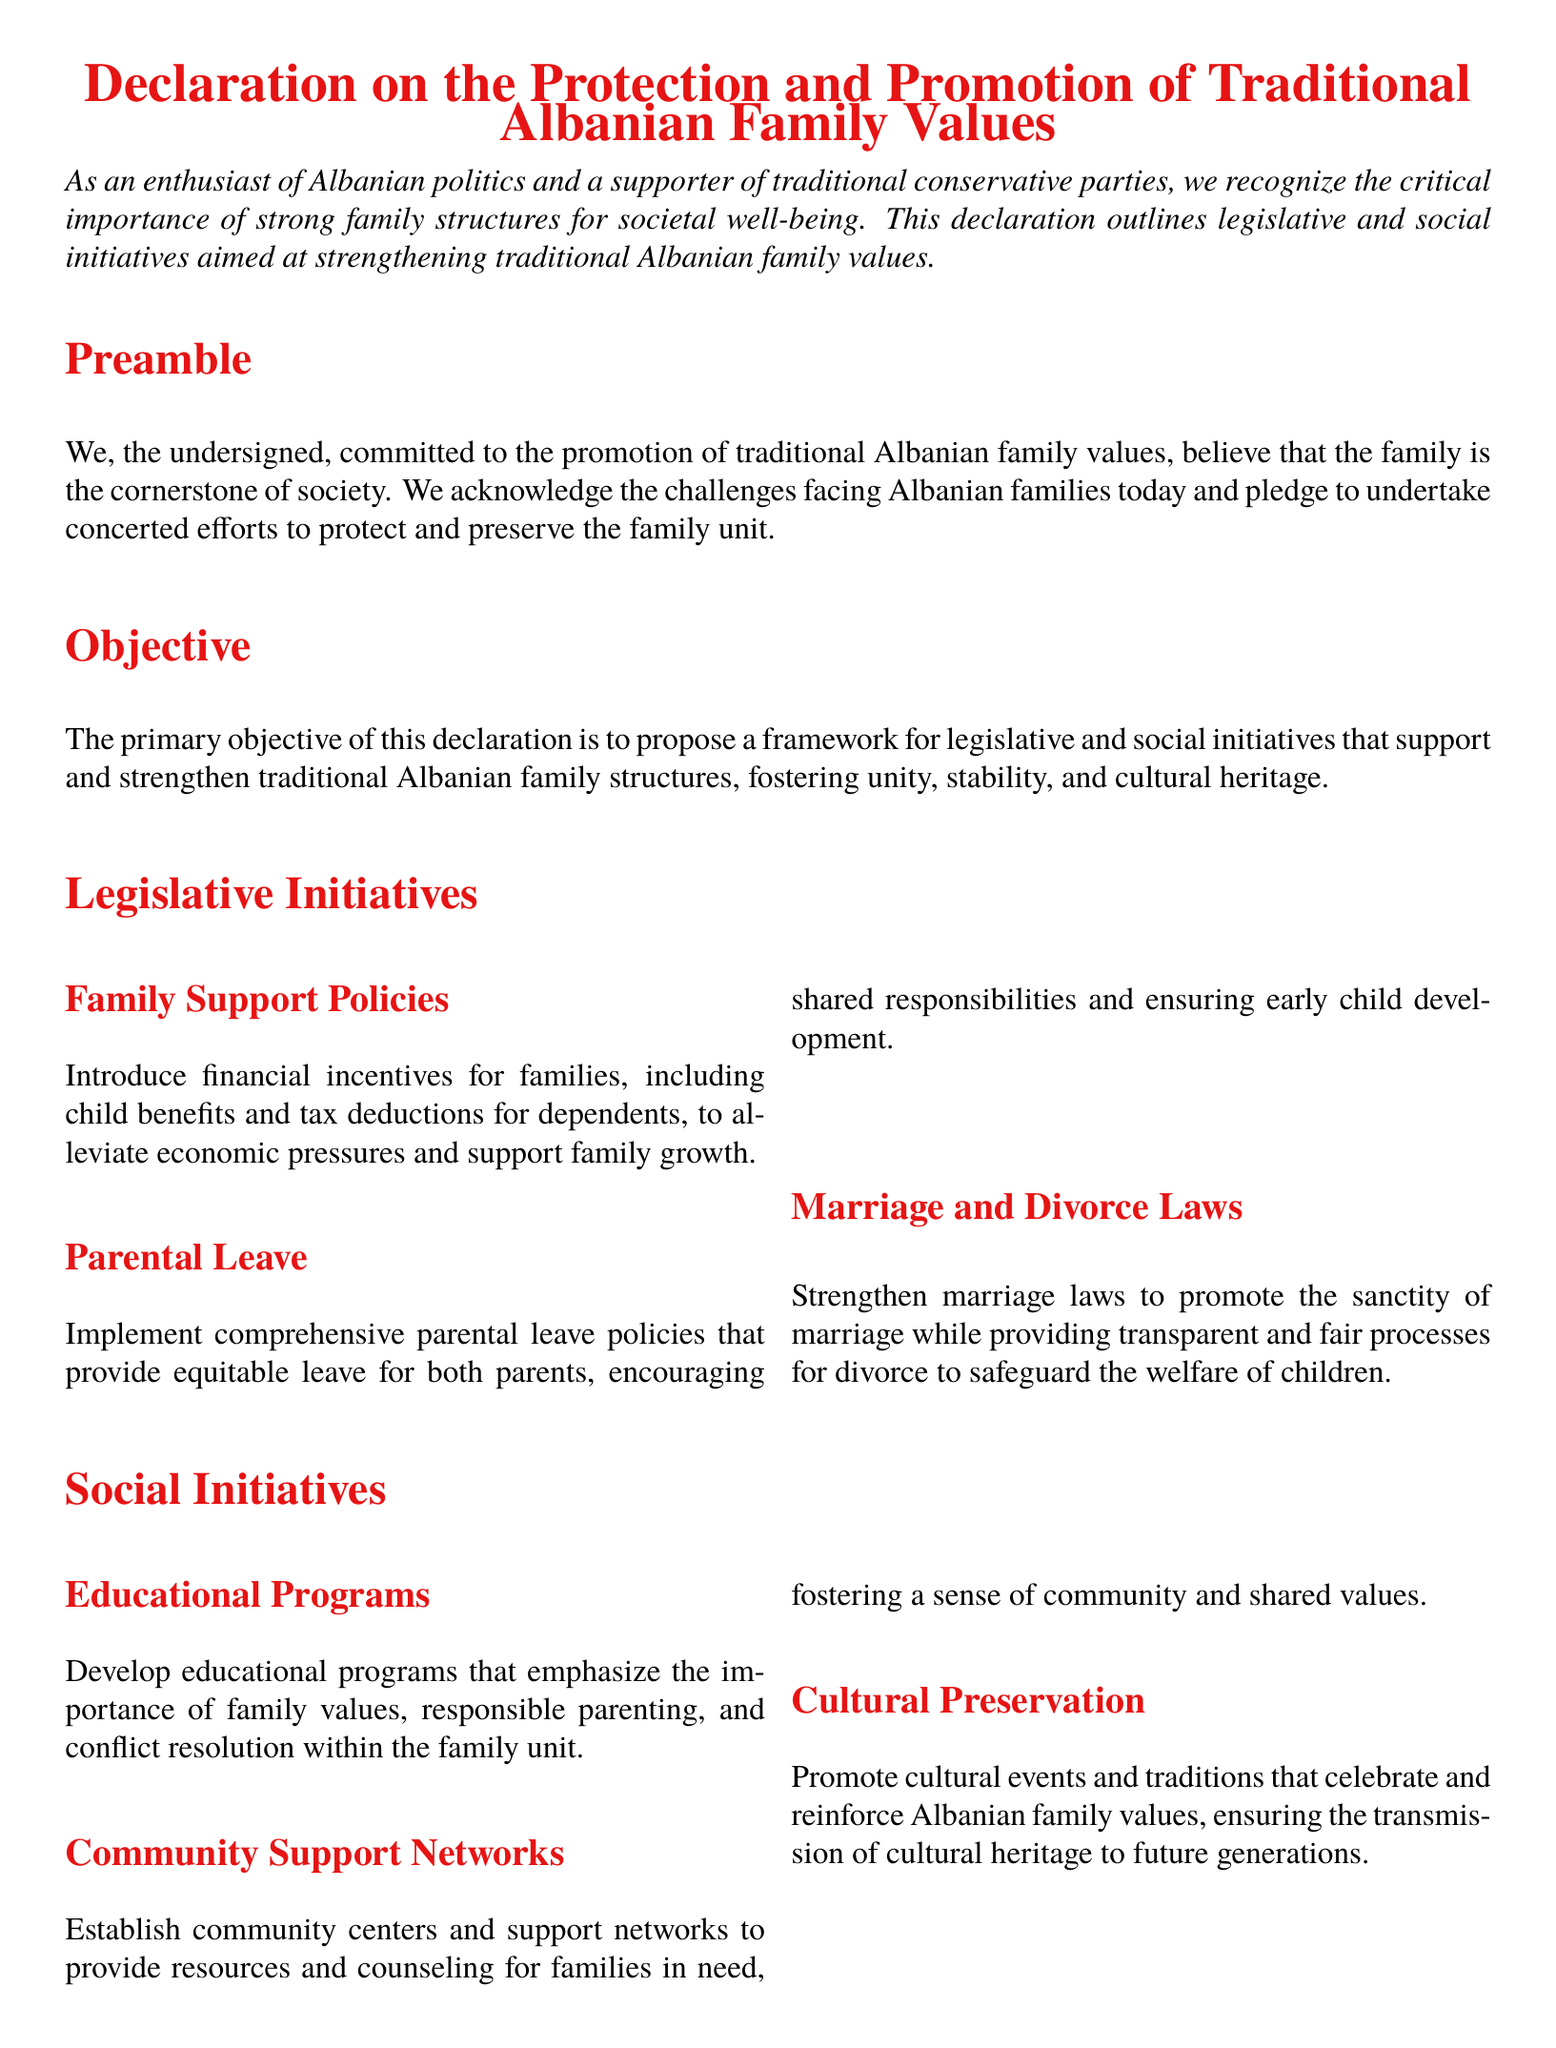What is the title of the document? The title is found at the beginning of the document.
Answer: Declaration on the Protection and Promotion of Traditional Albanian Family Values What color is used for headings in the document? The document specifies a color for headings.
Answer: Albanian red What is the primary objective of the declaration? The objective is provided in the section titled "Objective."
Answer: To propose a framework for legislative and social initiatives What type of leave is recommended for parents? This information is found under "Legislative Initiatives."
Answer: Parental leave What do educational programs aim to emphasize? The purpose of educational programs is mentioned in the "Social Initiatives" section.
Answer: Importance of family values What is one method proposed for community support? The document lists various initiatives under "Social Initiatives."
Answer: Establish community centers How do the signatories relate to the declaration? This is explained in the "Signatories" section.
Answer: Endorsed by relevant stakeholders How many columns are used for legislative and social initiatives? The document layout indicates the structure used for these sections.
Answer: Two columns What is the conclusion's commitment towards family values? The conclusion summarizes the document's core commitment.
Answer: Upholding and promoting these initiatives 